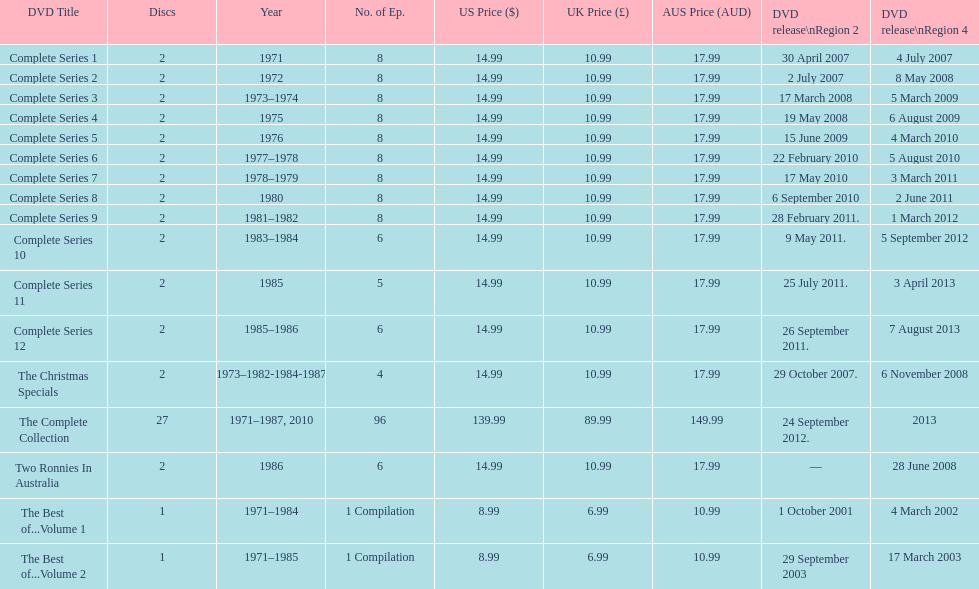Write the full table. {'header': ['DVD Title', 'Discs', 'Year', 'No. of Ep.', 'US Price ($)', 'UK Price (£)', 'AUS Price (AUD)', 'DVD release\\nRegion 2', 'DVD release\\nRegion 4'], 'rows': [['Complete Series 1', '2', '1971', '8', '14.99', '10.99', '17.99', '30 April 2007', '4 July 2007'], ['Complete Series 2', '2', '1972', '8', '14.99', '10.99', '17.99', '2 July 2007', '8 May 2008'], ['Complete Series 3', '2', '1973–1974', '8', '14.99', '10.99', '17.99', '17 March 2008', '5 March 2009'], ['Complete Series 4', '2', '1975', '8', '14.99', '10.99', '17.99', '19 May 2008', '6 August 2009'], ['Complete Series 5', '2', '1976', '8', '14.99', '10.99', '17.99', '15 June 2009', '4 March 2010'], ['Complete Series 6', '2', '1977–1978', '8', '14.99', '10.99', '17.99', '22 February 2010', '5 August 2010'], ['Complete Series 7', '2', '1978–1979', '8', '14.99', '10.99', '17.99', '17 May 2010', '3 March 2011'], ['Complete Series 8', '2', '1980', '8', '14.99', '10.99', '17.99', '6 September 2010', '2 June 2011'], ['Complete Series 9', '2', '1981–1982', '8', '14.99', '10.99', '17.99', '28 February 2011.', '1 March 2012'], ['Complete Series 10', '2', '1983–1984', '6', '14.99', '10.99', '17.99', '9 May 2011.', '5 September 2012'], ['Complete Series 11', '2', '1985', '5', '14.99', '10.99', '17.99', '25 July 2011.', '3 April 2013'], ['Complete Series 12', '2', '1985–1986', '6', '14.99', '10.99', '17.99', '26 September 2011.', '7 August 2013'], ['The Christmas Specials', '2', '1973–1982-1984-1987', '4', '14.99', '10.99', '17.99', '29 October 2007.', '6 November 2008'], ['The Complete Collection', '27', '1971–1987, 2010', '96', '139.99', '89.99', '149.99', '24 September 2012.', '2013'], ['Two Ronnies In Australia', '2', '1986', '6', '14.99', '10.99', '17.99', '—', '28 June 2008'], ['The Best of...Volume 1', '1', '1971–1984', '1 Compilation', '8.99', '6.99', '10.99', '1 October 2001', '4 March 2002'], ['The Best of...Volume 2', '1', '1971–1985', '1 Compilation', '8.99', '6.99', '10.99', '29 September 2003', '17 March 2003']]} The complete collection has 96 episodes, but the christmas specials only has how many episodes? 4. 